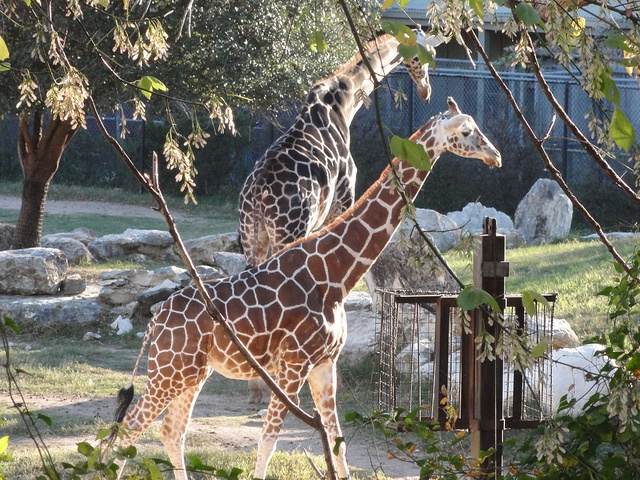Describe the objects in this image and their specific colors. I can see giraffe in gray, maroon, and lightgray tones and giraffe in gray, black, darkgray, and ivory tones in this image. 